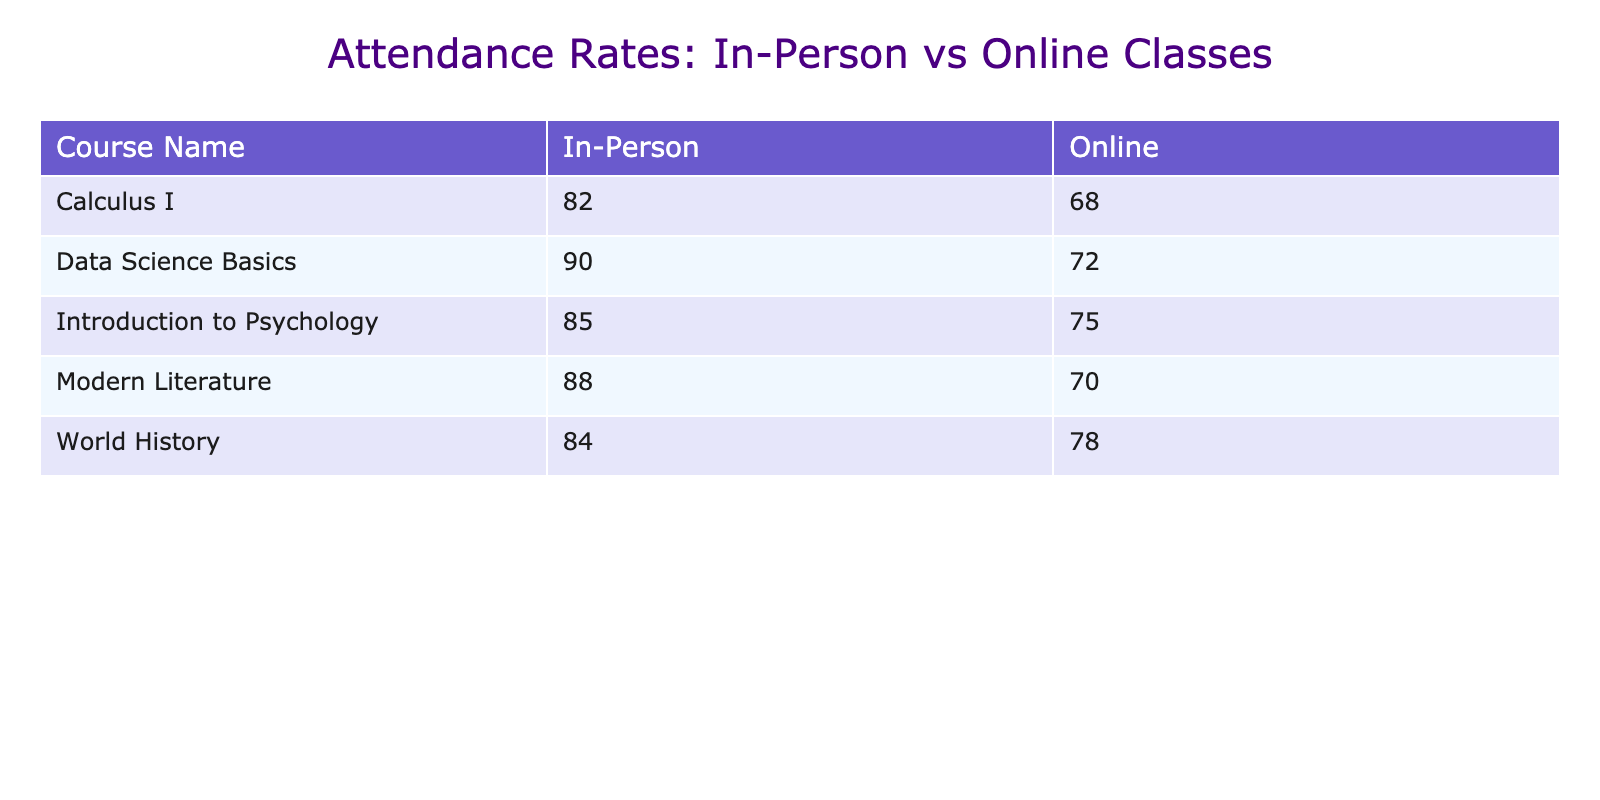What's the attendance rate for In-Person classes in Data Science Basics? The table shows that the attendance rate for In-Person classes in Data Science Basics is 90%. This value can be found directly in the corresponding row and column for this course.
Answer: 90% What is the attendance rate for Online classes in World History? According to the table, the attendance rate for Online classes in World History is 78%. This information is present in the relevant row and column.
Answer: 78% Which class has the highest attendance rate and what is that rate? The highest attendance rate is found in the In-Person class for Data Science Basics, which has an attendance rate of 90%. I determined this by comparing attendance rates across all the courses listed in the table.
Answer: 90% What is the average attendance rate for Online classes across all courses? To calculate the average attendance rate for Online classes, I summed the attendance rates for all Online classes (75 + 68 + 70 + 72 + 78 = 363) and divided by the number of Online classes (5). This gives an average rate of 72.6%.
Answer: 72.6% Is the attendance rate for Online classes in Calculus I higher than in Modern Literature? The attendance rate for Online classes in Calculus I is 68%, while in Modern Literature it is 70%. Therefore, the attendance rate for Online classes in Calculus I is not higher. I compared the two rates directly from the table.
Answer: No How does the attendance rate for In-Person classes compare to Online classes for Introduction to Psychology? The In-Person attendance rate for Introduction to Psychology is 85%, while the Online attendance rate is 75%. This shows that In-Person attendance is higher than Online. I checked both rates from the relevant rows of the table.
Answer: In-Person is higher Which instructor has the lowest attendance rate for their Online class, and what is that rate? Dr. Michael Brown has the lowest attendance rate for his Online Calculus I class at 68%. I compared the Online attendance rates across all courses and identified this lowest value specifically linked to his class.
Answer: 68% If we increase the attendance rate of Online classes by 5%, what would be the new rate for Data Science Basics? The current attendance rate for Online Data Science Basics is 72%. If we add 5% to this, the new attendance rate would be 77%. I calculated this by simply adding 5 to the current rate.
Answer: 77% Is the attendance rate for In-Person classes consistently higher than that for Online classes across all courses? No, in Calculus I the In-Person attendance rate (82%) is higher than Online (68%), and in Modern Literature, In-Person (88%) is higher than Online (70%). However, for World History, the In-Person rate is 84%, while Online is 78%. This shows a consistent pattern of higher rates for In-Person classes, but they are still lower compared to the rates in other specific classes.
Answer: Yes 